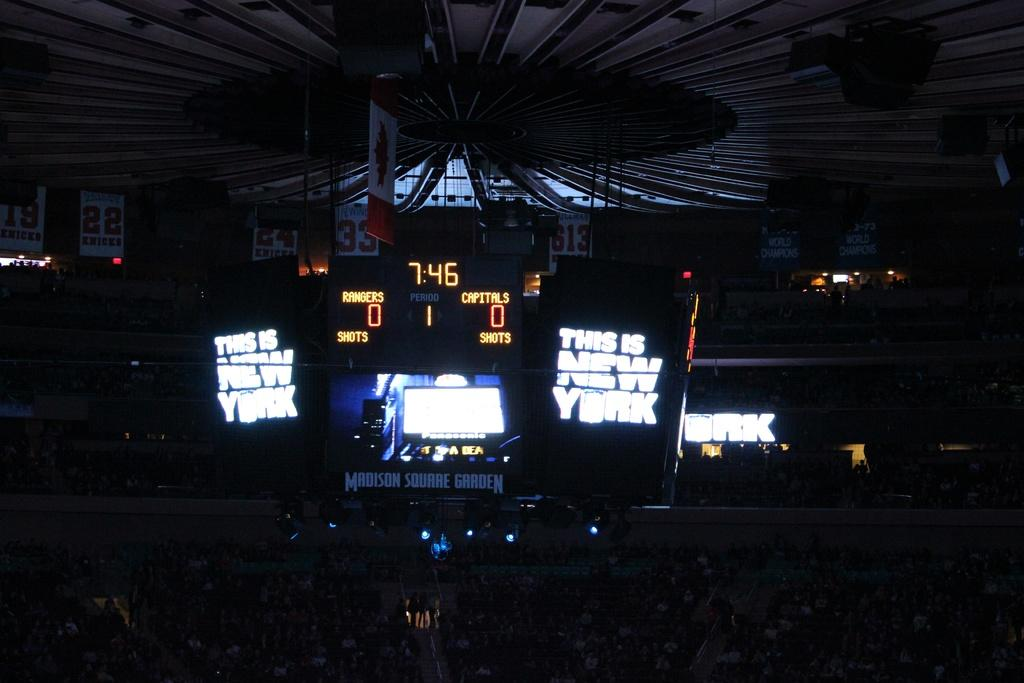<image>
Share a concise interpretation of the image provided. A huge scoreboard hangs from the ceiling at a basketball court and tells is there is 7.46 to go and the score is zero each 